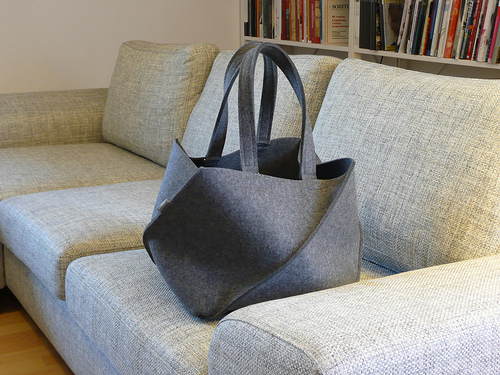<image>
Can you confirm if the sofa is on the bag? No. The sofa is not positioned on the bag. They may be near each other, but the sofa is not supported by or resting on top of the bag. 